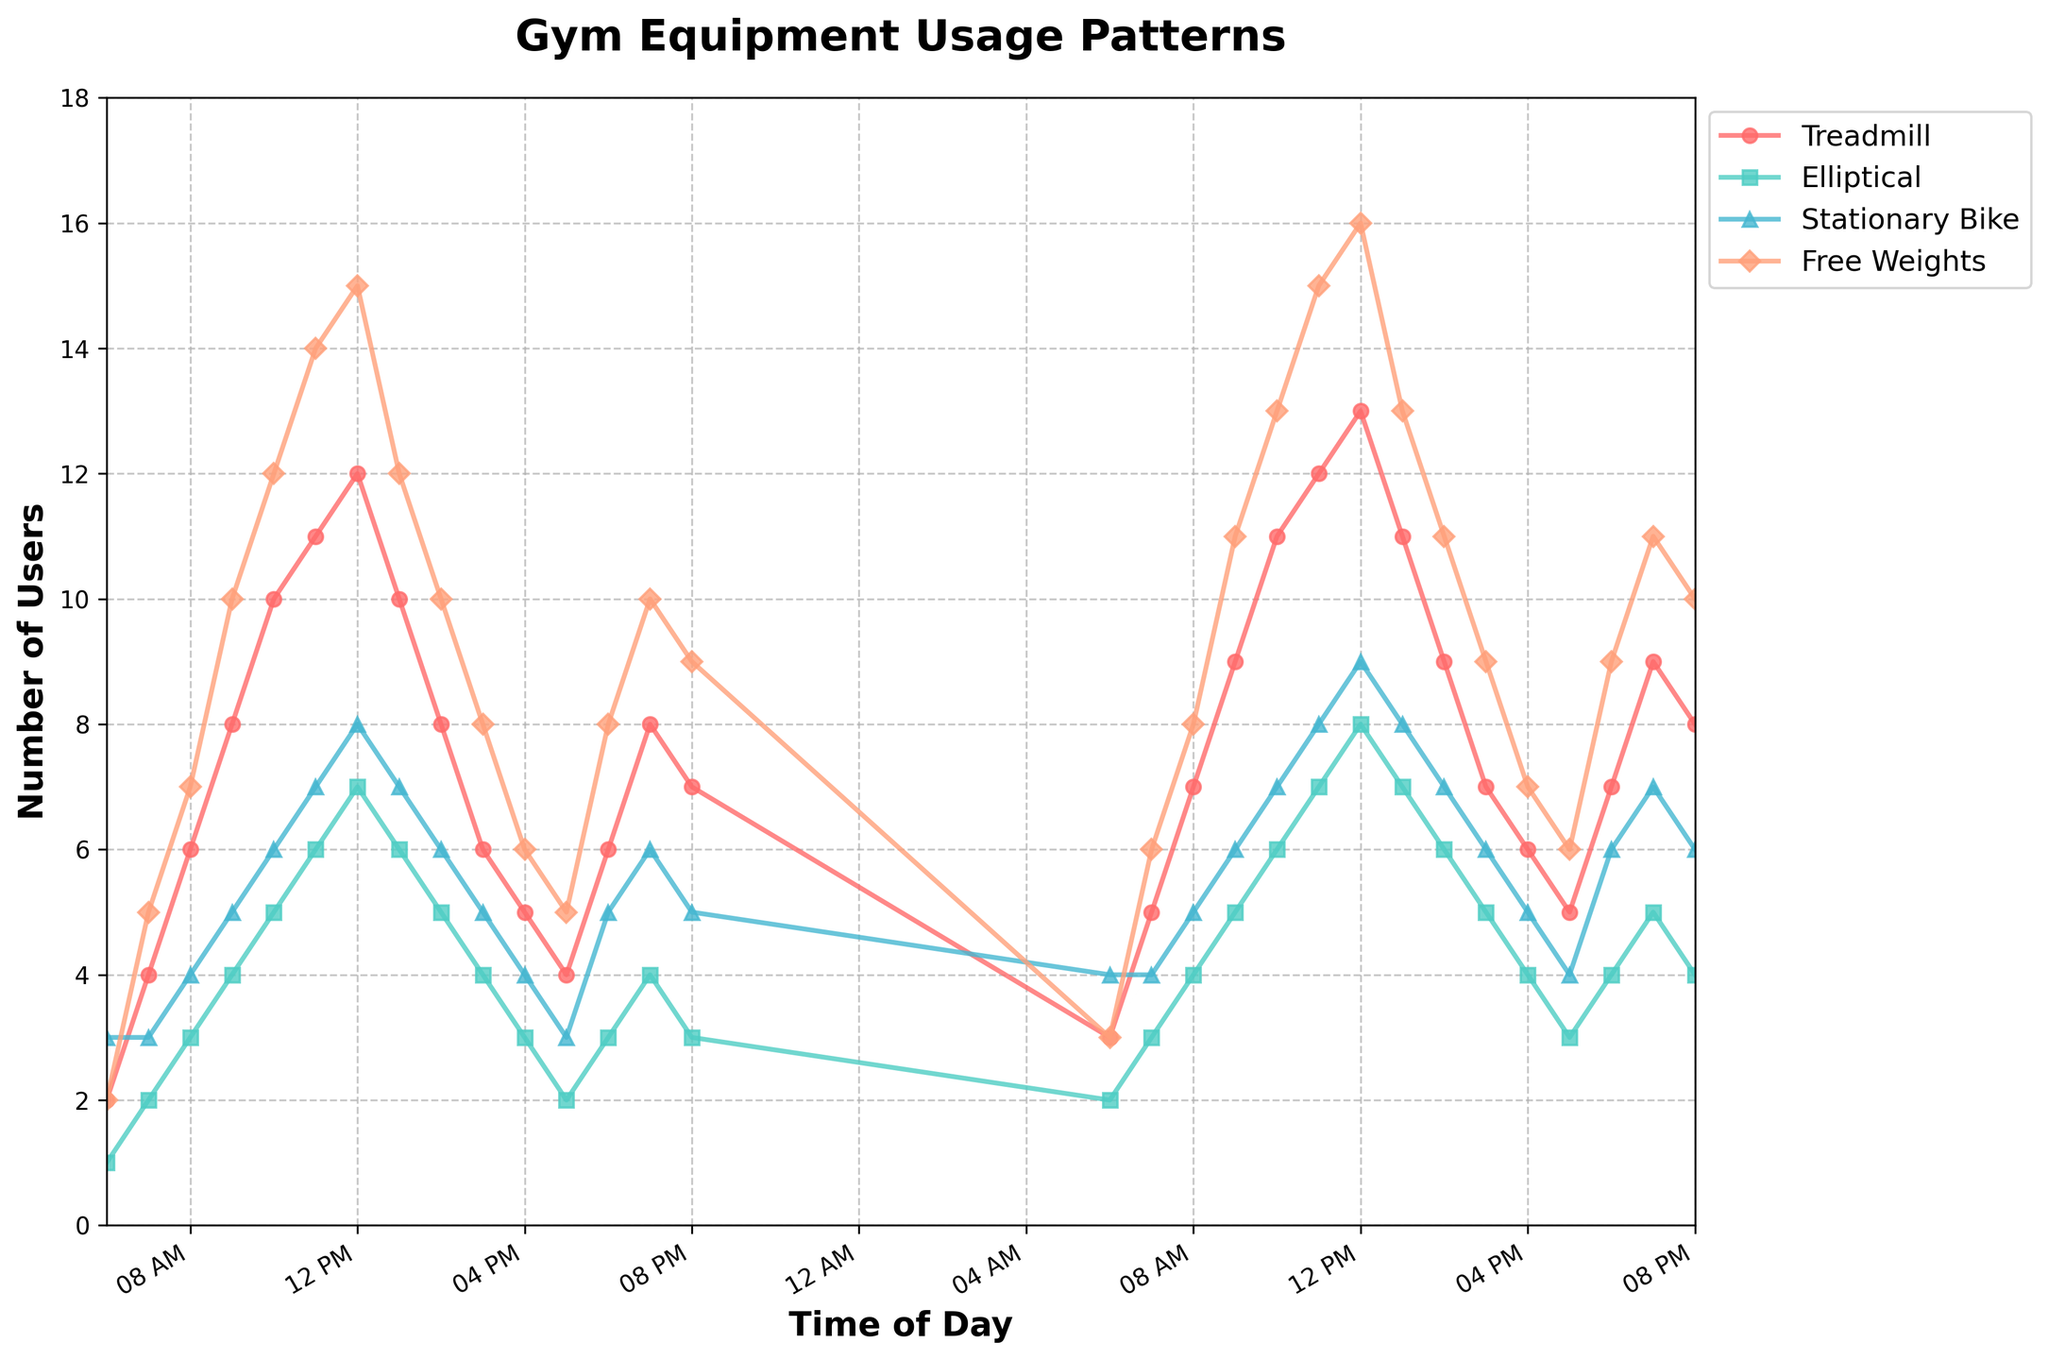What is the title of the plot? The title of the plot is displayed prominently at the top of the figure.
Answer: Gym Equipment Usage Patterns What is the label for the Y-axis? The label for the Y-axis can be seen along the left side of the plot.
Answer: Number of Users At what time of day is the usage of Treadmills the highest? To find the peak usage time for Treadmills, locate the highest point in the red line representing Treadmills.
Answer: 12:00 PM What are the colors used to represent Elliptical and Free Weights? Check the legend to identify the colors associated with each equipment type.
Answer: Elliptical: teal, Free Weights: salmon How does the usage of Stationary Bikes at 11:00 PM compare to the usage at 8:00 AM? Compare the height of the red marker at 11:00 PM with that at 8:00 AM.
Answer: Higher at 8:00 AM Which equipment shows a consistent increase in usage through the morning hours? Identify which equipment's line is steadily increasing from early morning to around noon.
Answer: Treadmill If you sum up the peak usages across all equipment types, what is the total number of users? Identify the maximum usage for each equipment type and add these values together.
Answer: 54 How many data points are plotted for Free Weights at 2:00 PM? Count how many markers of any color are plotted along the X-axis at 2:00 PM.
Answer: 1 Between Treadmill and Elliptical, which equipment has a more consistent usage pattern throughout the day? Assess the fluctuations in the lines for Treadmill and Elliptical to determine which is more consistent.
Answer: Elliptical What is the general trend in equipment usage during evening hours (6:00 PM - 8:00 PM)? Examine the lines for all equipment types from 6:00 PM to 8:00 PM to identify any upward or downward trends.
Answer: Generally increasing 